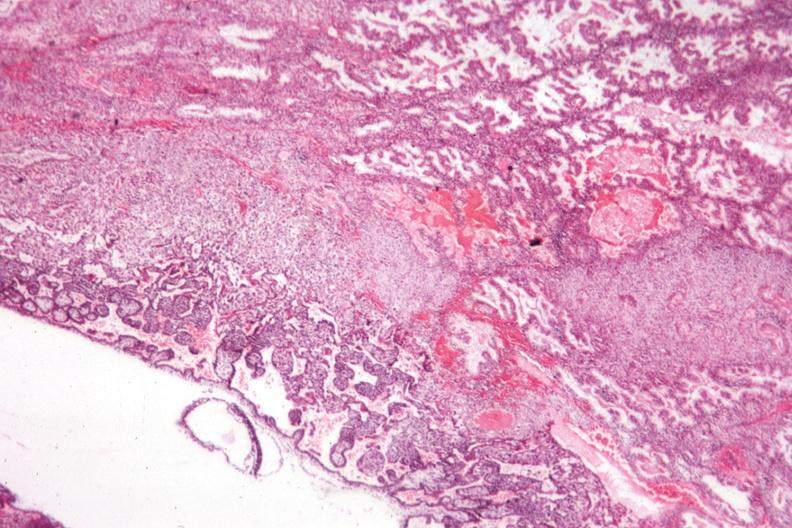what is present?
Answer the question using a single word or phrase. Uterus 